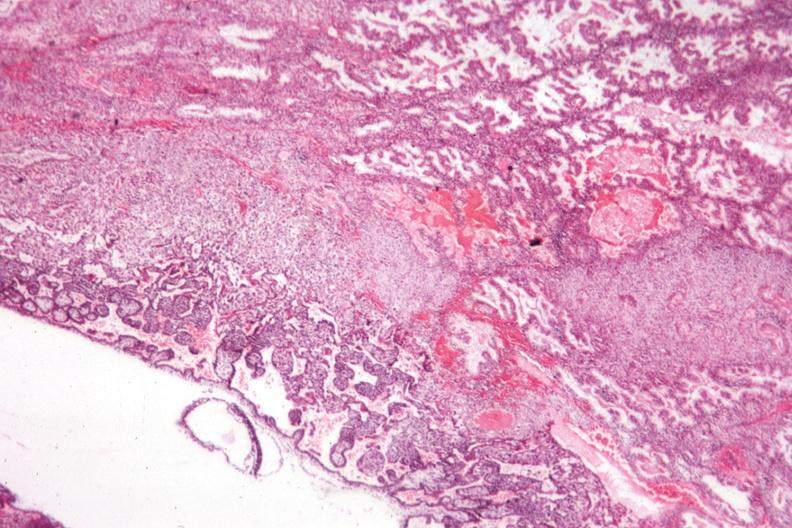what is present?
Answer the question using a single word or phrase. Uterus 